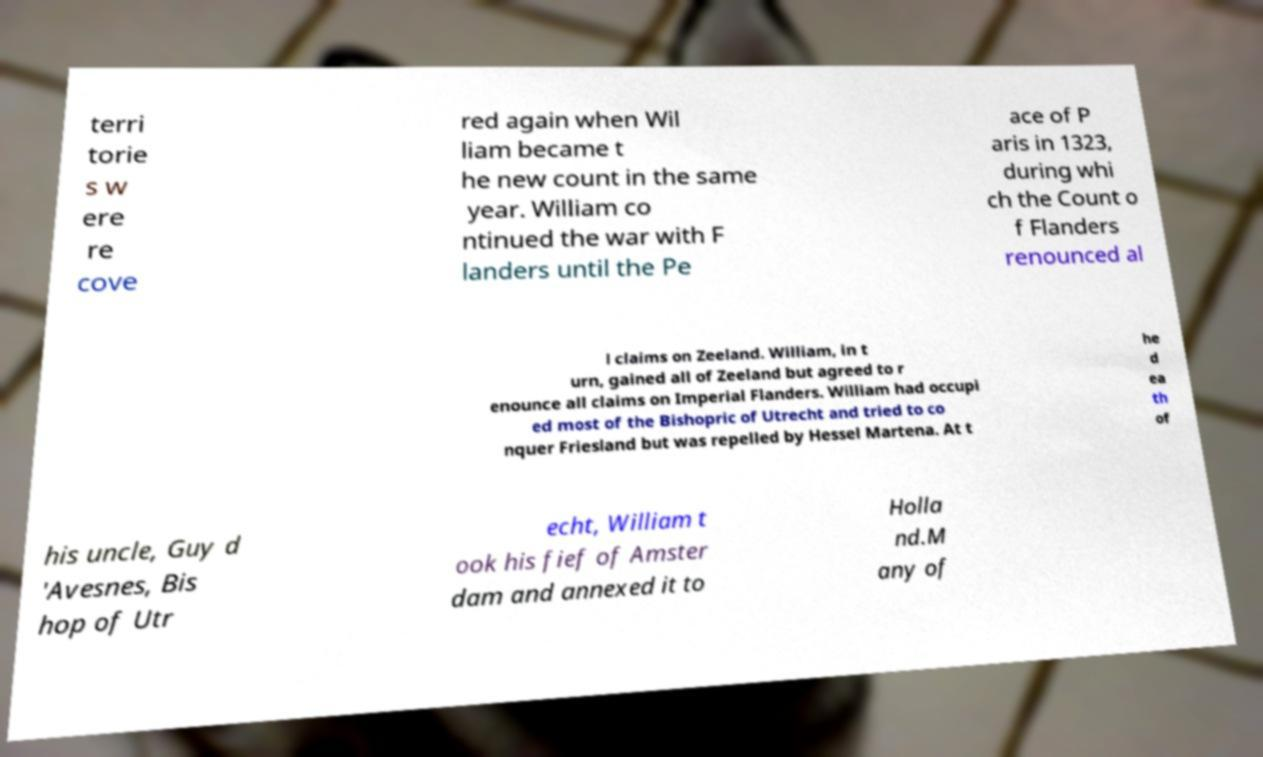For documentation purposes, I need the text within this image transcribed. Could you provide that? terri torie s w ere re cove red again when Wil liam became t he new count in the same year. William co ntinued the war with F landers until the Pe ace of P aris in 1323, during whi ch the Count o f Flanders renounced al l claims on Zeeland. William, in t urn, gained all of Zeeland but agreed to r enounce all claims on Imperial Flanders. William had occupi ed most of the Bishopric of Utrecht and tried to co nquer Friesland but was repelled by Hessel Martena. At t he d ea th of his uncle, Guy d 'Avesnes, Bis hop of Utr echt, William t ook his fief of Amster dam and annexed it to Holla nd.M any of 